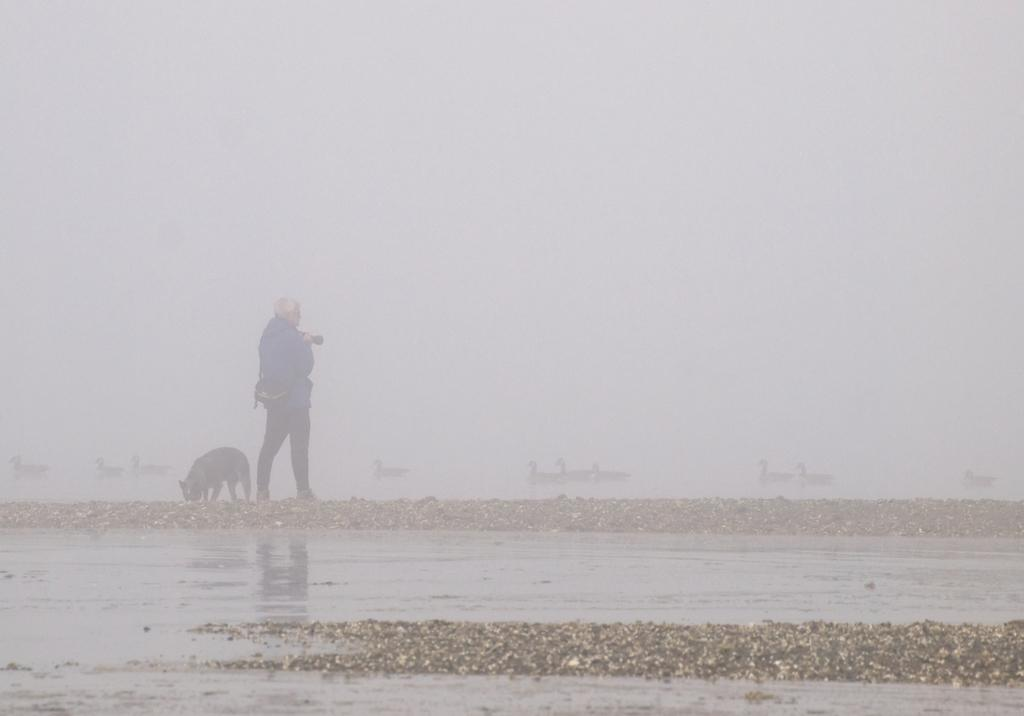What type of animal is in the image? There is a dog in the image. Who or what else is in the image? There is a person and birds in the image. What is the environment like in the image? There is water visible in the image. What is near the person in the image? There are objects near the person in the image. What is the cause of the oven's malfunction in the image? There is no oven present in the image, so it is not possible to determine the cause of any malfunction. 